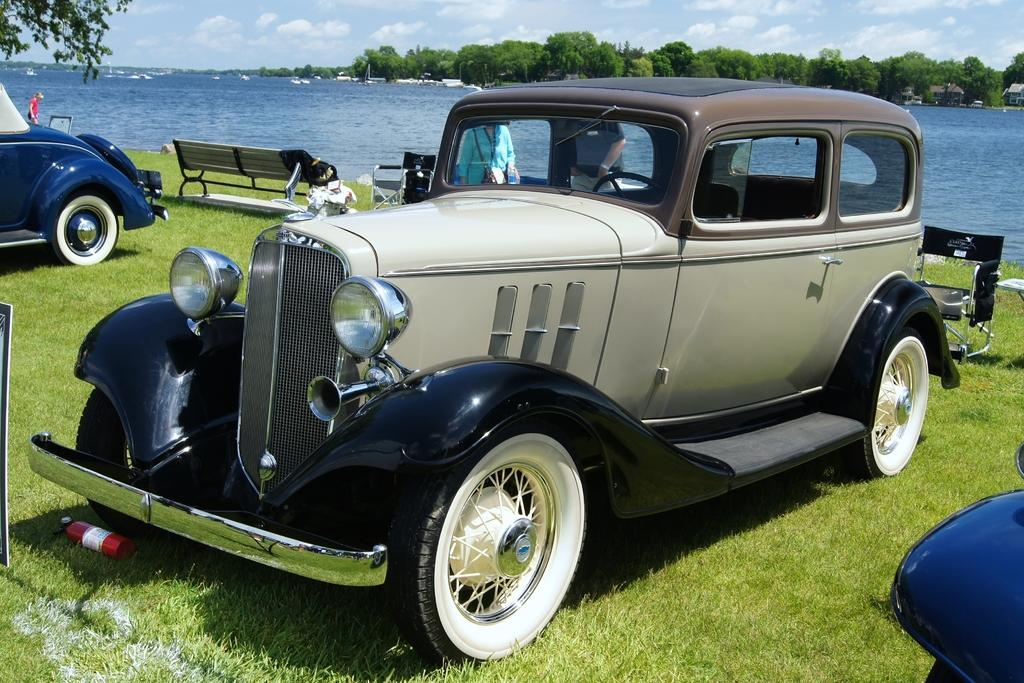What is located in the center of the image? There are vehicles in the center of the image. What can be seen in the background of the image? There are benches, trees, a river, and the sky visible in the background of the image. What type of vegetation is present at the bottom of the image? There is grass at the bottom of the image. What type of skirt is being worn by the river in the image? There is no skirt present in the image, as the river is a natural body of water. Can you tell me how much cheese is visible in the image? There is no cheese present in the image. 